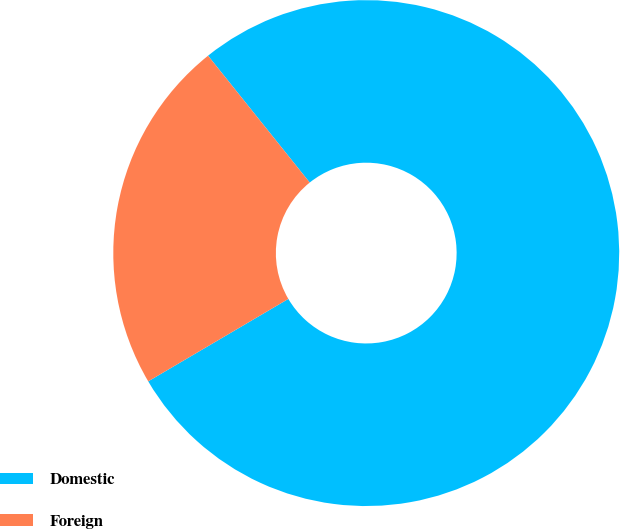Convert chart to OTSL. <chart><loc_0><loc_0><loc_500><loc_500><pie_chart><fcel>Domestic<fcel>Foreign<nl><fcel>77.29%<fcel>22.71%<nl></chart> 